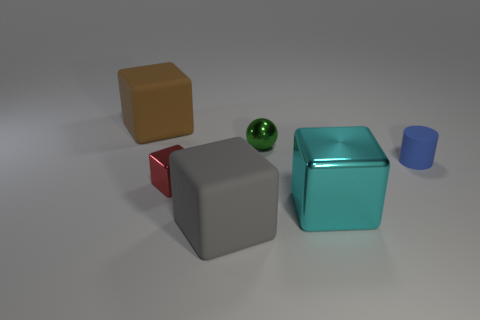Subtract all big brown rubber blocks. How many blocks are left? 3 Subtract all red blocks. How many blocks are left? 3 Subtract 1 balls. How many balls are left? 0 Add 3 tiny gray matte cubes. How many objects exist? 9 Subtract all cubes. How many objects are left? 2 Subtract all gray balls. Subtract all red cylinders. How many balls are left? 1 Add 5 small green balls. How many small green balls exist? 6 Subtract 0 gray spheres. How many objects are left? 6 Subtract all small red metal blocks. Subtract all small red metal blocks. How many objects are left? 4 Add 5 cyan shiny cubes. How many cyan shiny cubes are left? 6 